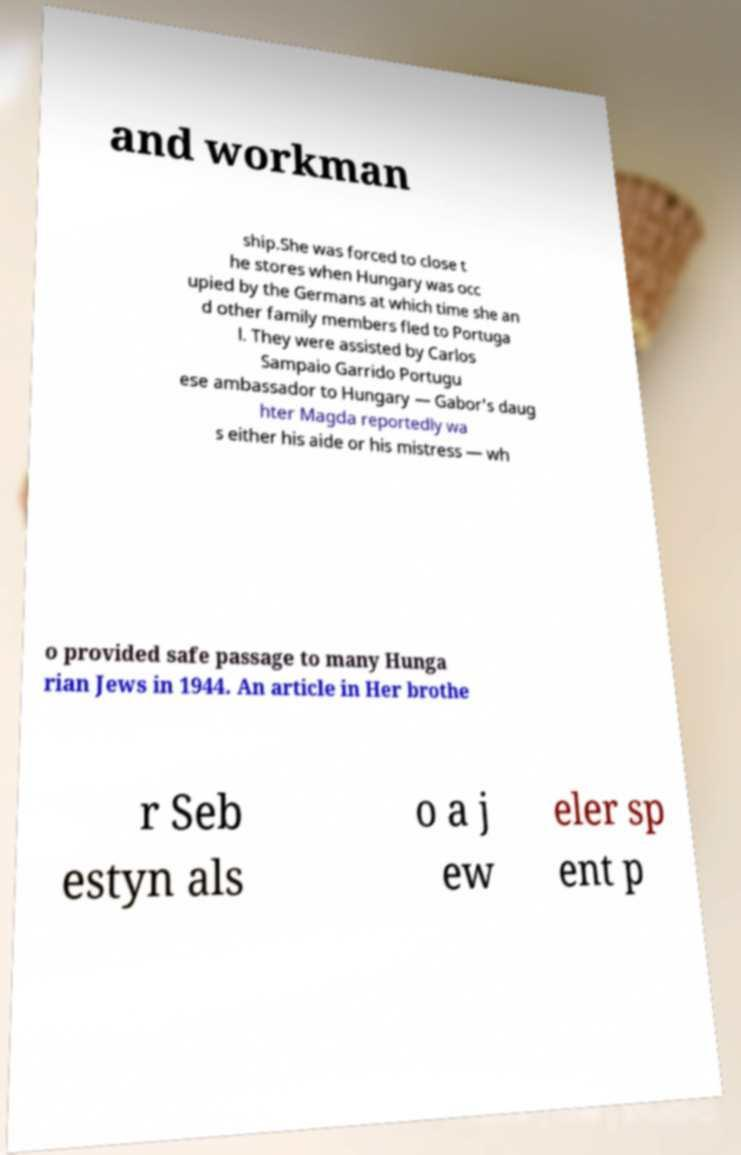For documentation purposes, I need the text within this image transcribed. Could you provide that? and workman ship.She was forced to close t he stores when Hungary was occ upied by the Germans at which time she an d other family members fled to Portuga l. They were assisted by Carlos Sampaio Garrido Portugu ese ambassador to Hungary — Gabor's daug hter Magda reportedly wa s either his aide or his mistress — wh o provided safe passage to many Hunga rian Jews in 1944. An article in Her brothe r Seb estyn als o a j ew eler sp ent p 